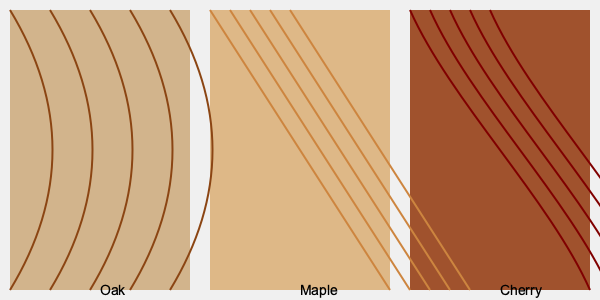Which of the wood grain patterns shown would be most suitable for a traditional Shaker-style kitchen cabinet design? To determine the most suitable wood grain pattern for a traditional Shaker-style kitchen cabinet design, let's consider the characteristics of each wood type and the Shaker style:

1. Oak (left pattern):
   - Strong, prominent grain with a wavy pattern
   - Durable and resistant to wear
   - Traditional look with a rustic feel

2. Maple (middle pattern):
   - Straight, fine grain with a subtle pattern
   - Hard and durable
   - Clean, simple appearance

3. Cherry (right pattern):
   - Flowing, curvy grain pattern
   - Smooth texture
   - Rich, warm color that darkens over time

Shaker-style cabinets are known for their:
- Simplicity and functionality
- Clean lines and minimal ornamentation
- Focus on craftsmanship and utility

Considering these factors:
- Oak's prominent grain might be too busy for the simple Shaker style
- Cherry's flowing grain and rich color could overpower the minimalist Shaker design
- Maple's straight, fine grain and clean appearance aligns best with Shaker principles

Therefore, the maple wood grain pattern (middle) would be most suitable for a traditional Shaker-style kitchen cabinet design.
Answer: Maple 